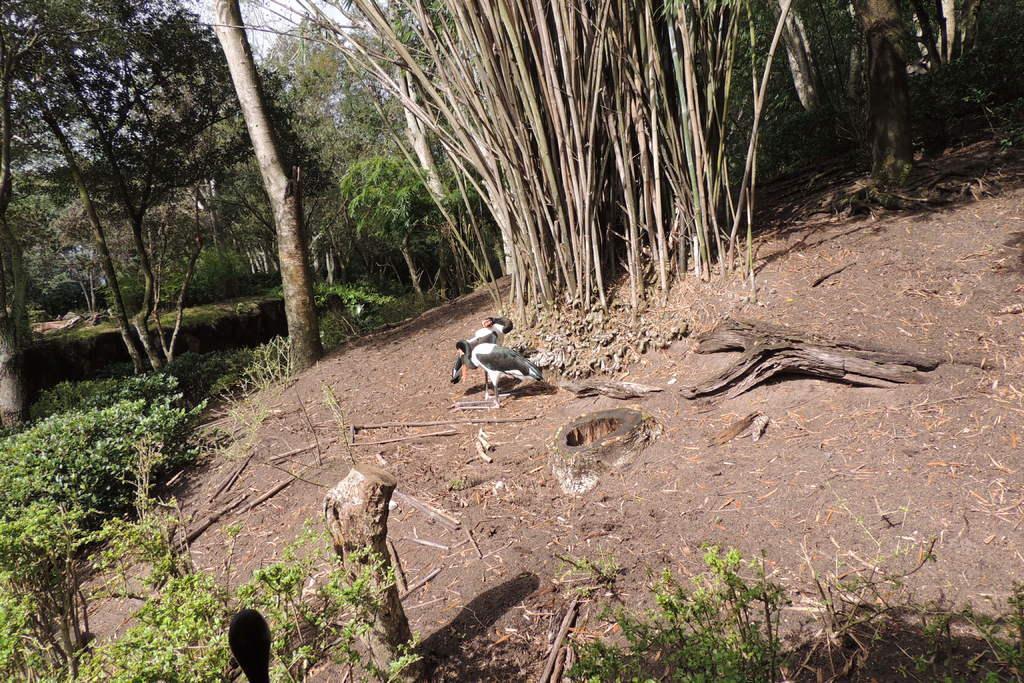Could you give a brief overview of what you see in this image? In this image I can see two birds, they are in white and gray color. Background I can see plants and trees in green color and the sky is in white color. 